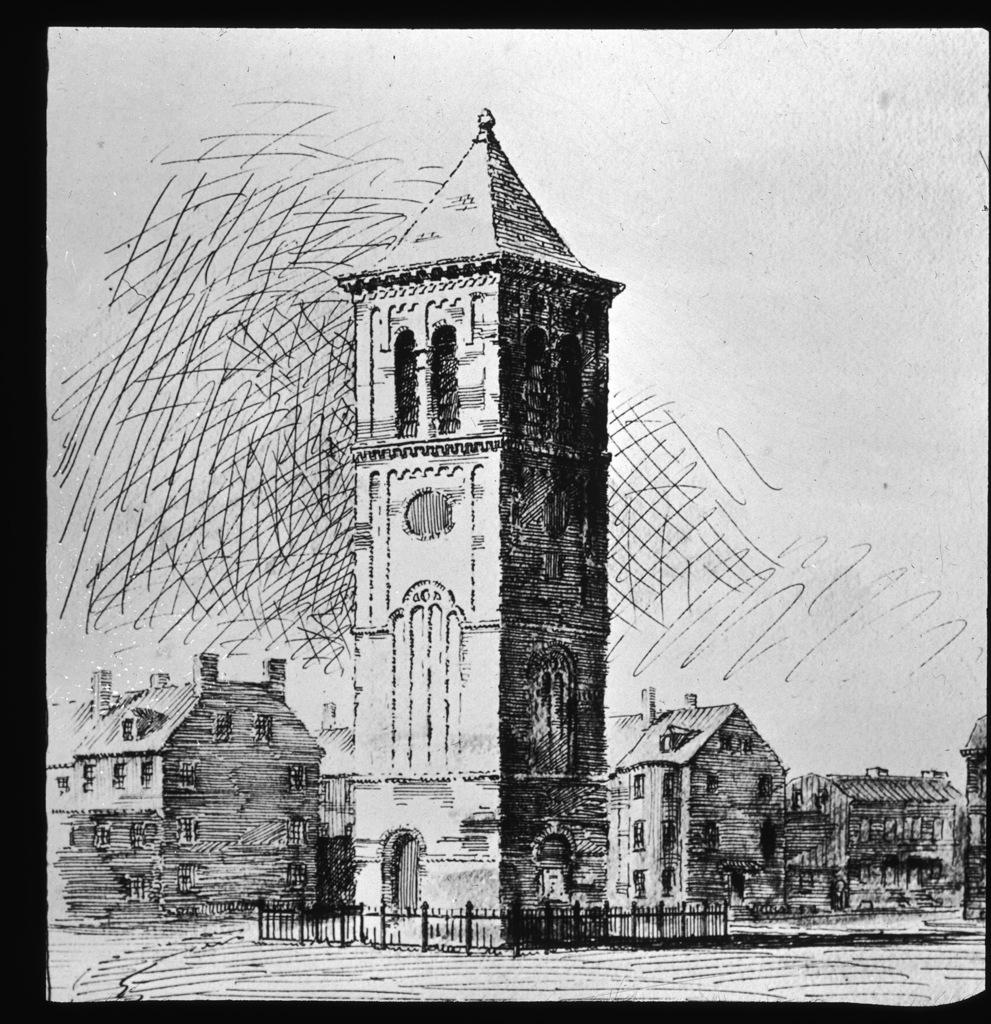What is the main structure in the image? There is a tower in the image. What other structures can be seen in the image? There are buildings in the image. What type of barrier is present in the image? There is a fence in the image. How much money is scattered on the ground in the image? There is no money present in the image; it only features a tower, buildings, and a fence. 